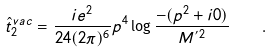Convert formula to latex. <formula><loc_0><loc_0><loc_500><loc_500>\hat { t } _ { 2 } ^ { v a c } = \frac { i e ^ { 2 } } { 2 4 ( 2 \pi ) ^ { 6 } } p ^ { 4 } \log \frac { - ( p ^ { 2 } + i 0 ) } { M ^ { ^ { \prime } 2 } } \quad .</formula> 